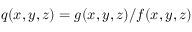<formula> <loc_0><loc_0><loc_500><loc_500>q ( x , y , z ) = g ( x , y , z ) / f ( x , y , z )</formula> 